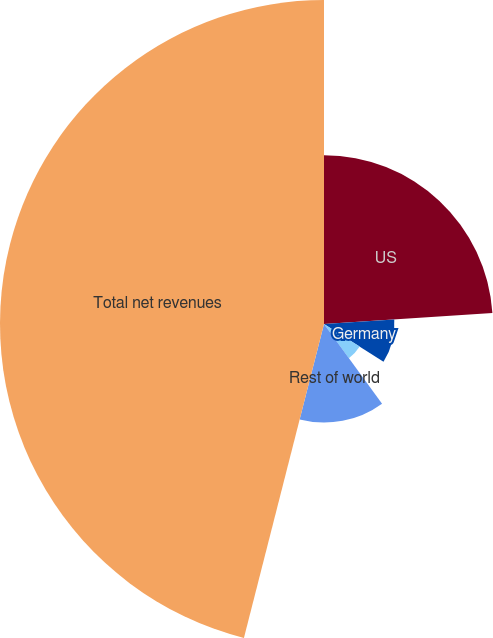Convert chart. <chart><loc_0><loc_0><loc_500><loc_500><pie_chart><fcel>US<fcel>Germany<fcel>United Kingdom<fcel>Rest of world<fcel>Total net revenues<nl><fcel>23.97%<fcel>10.0%<fcel>6.0%<fcel>14.0%<fcel>46.02%<nl></chart> 